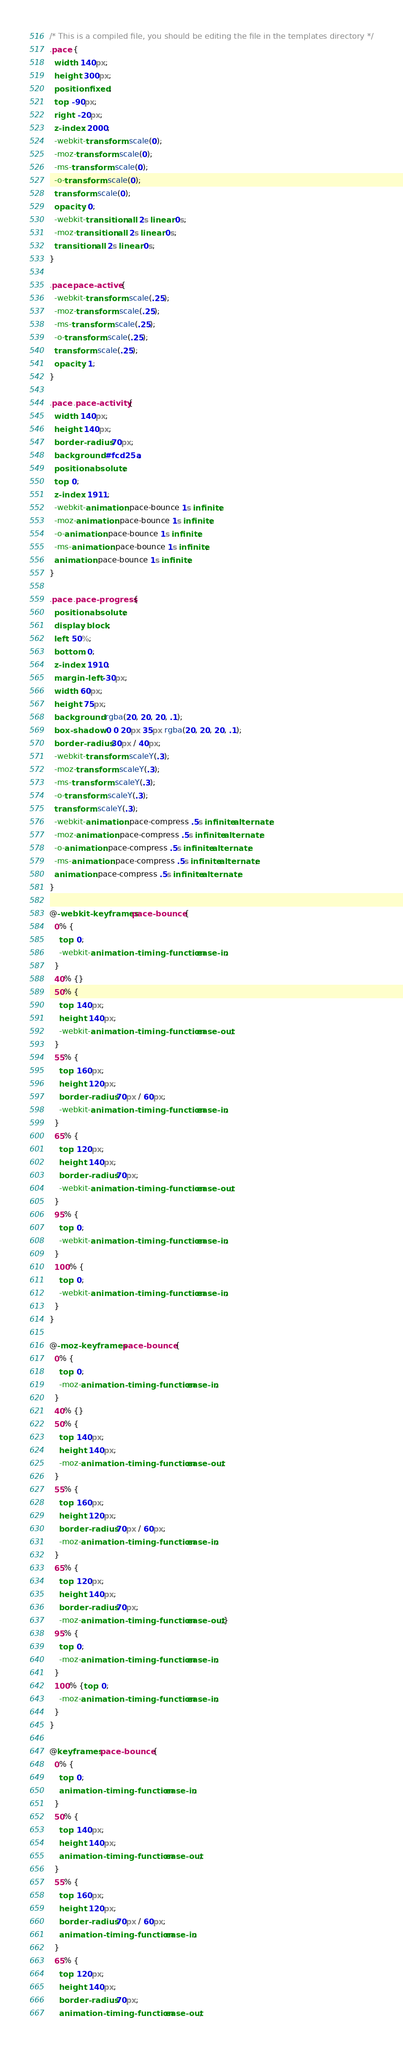<code> <loc_0><loc_0><loc_500><loc_500><_CSS_>/* This is a compiled file, you should be editing the file in the templates directory */
.pace {
  width: 140px;
  height: 300px;
  position: fixed;
  top: -90px;
  right: -20px;
  z-index: 2000;
  -webkit-transform: scale(0);
  -moz-transform: scale(0);
  -ms-transform: scale(0);
  -o-transform: scale(0);
  transform: scale(0);
  opacity: 0;
  -webkit-transition: all 2s linear 0s;
  -moz-transition: all 2s linear 0s;
  transition: all 2s linear 0s;
}

.pace.pace-active {
  -webkit-transform: scale(.25);
  -moz-transform: scale(.25);
  -ms-transform: scale(.25);
  -o-transform: scale(.25);
  transform: scale(.25);
  opacity: 1;
}

.pace .pace-activity {
  width: 140px;
  height: 140px;
  border-radius: 70px;
  background: #fcd25a;
  position: absolute;
  top: 0;
  z-index: 1911;
  -webkit-animation: pace-bounce 1s infinite;
  -moz-animation: pace-bounce 1s infinite;
  -o-animation: pace-bounce 1s infinite;
  -ms-animation: pace-bounce 1s infinite;
  animation: pace-bounce 1s infinite;
}

.pace .pace-progress {
  position: absolute;
  display: block;
  left: 50%;
  bottom: 0;
  z-index: 1910;
  margin-left: -30px;
  width: 60px;
  height: 75px;
  background: rgba(20, 20, 20, .1);
  box-shadow: 0 0 20px 35px rgba(20, 20, 20, .1);
  border-radius: 30px / 40px;
  -webkit-transform: scaleY(.3);
  -moz-transform: scaleY(.3);
  -ms-transform: scaleY(.3);
  -o-transform: scaleY(.3);
  transform: scaleY(.3);
  -webkit-animation: pace-compress .5s infinite alternate;
  -moz-animation: pace-compress .5s infinite alternate;
  -o-animation: pace-compress .5s infinite alternate;
  -ms-animation: pace-compress .5s infinite alternate;
  animation: pace-compress .5s infinite alternate;
}

@-webkit-keyframes pace-bounce {
  0% {
    top: 0;
    -webkit-animation-timing-function: ease-in;
  }
  40% {}
  50% {
    top: 140px;
    height: 140px;
    -webkit-animation-timing-function: ease-out;
  }
  55% {
    top: 160px;
    height: 120px;
    border-radius: 70px / 60px;
    -webkit-animation-timing-function: ease-in;
  }
  65% {
    top: 120px;
    height: 140px;
    border-radius: 70px;
    -webkit-animation-timing-function: ease-out;
  }
  95% {
    top: 0;
    -webkit-animation-timing-function: ease-in;
  }
  100% {
    top: 0;
    -webkit-animation-timing-function: ease-in;
  }
}

@-moz-keyframes pace-bounce {
  0% {
    top: 0;
    -moz-animation-timing-function: ease-in;
  }
  40% {}
  50% {
    top: 140px;
    height: 140px;
    -moz-animation-timing-function: ease-out;
  }
  55% {
    top: 160px;
    height: 120px;
    border-radius: 70px / 60px;
    -moz-animation-timing-function: ease-in;
  }
  65% {
    top: 120px;
    height: 140px;
    border-radius: 70px;
    -moz-animation-timing-function: ease-out;}
  95% {
    top: 0;
    -moz-animation-timing-function: ease-in;
  }
  100% {top: 0;
    -moz-animation-timing-function: ease-in;
  }
}

@keyframes pace-bounce {
  0% {
    top: 0;
    animation-timing-function: ease-in;
  }
  50% {
    top: 140px;
    height: 140px;
    animation-timing-function: ease-out;
  }
  55% {
    top: 160px;
    height: 120px;
    border-radius: 70px / 60px;
    animation-timing-function: ease-in;
  }
  65% {
    top: 120px;
    height: 140px;
    border-radius: 70px;
    animation-timing-function: ease-out;</code> 